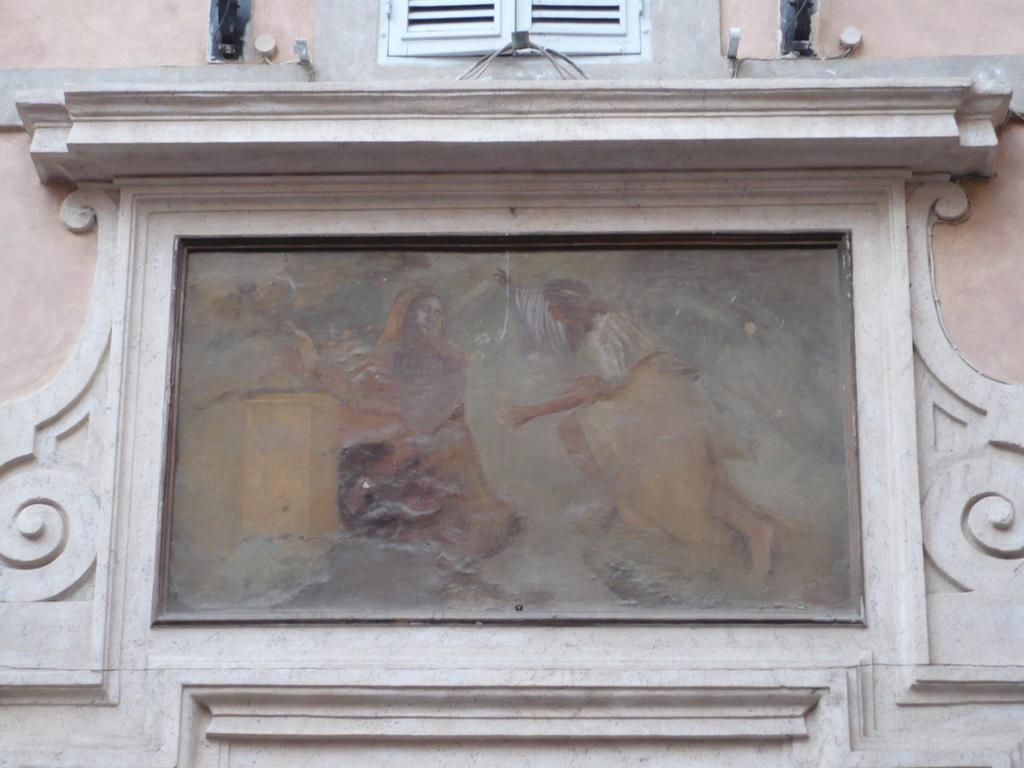Could you give a brief overview of what you see in this image? There is a portrait in the center of the image and a window at the top side. 